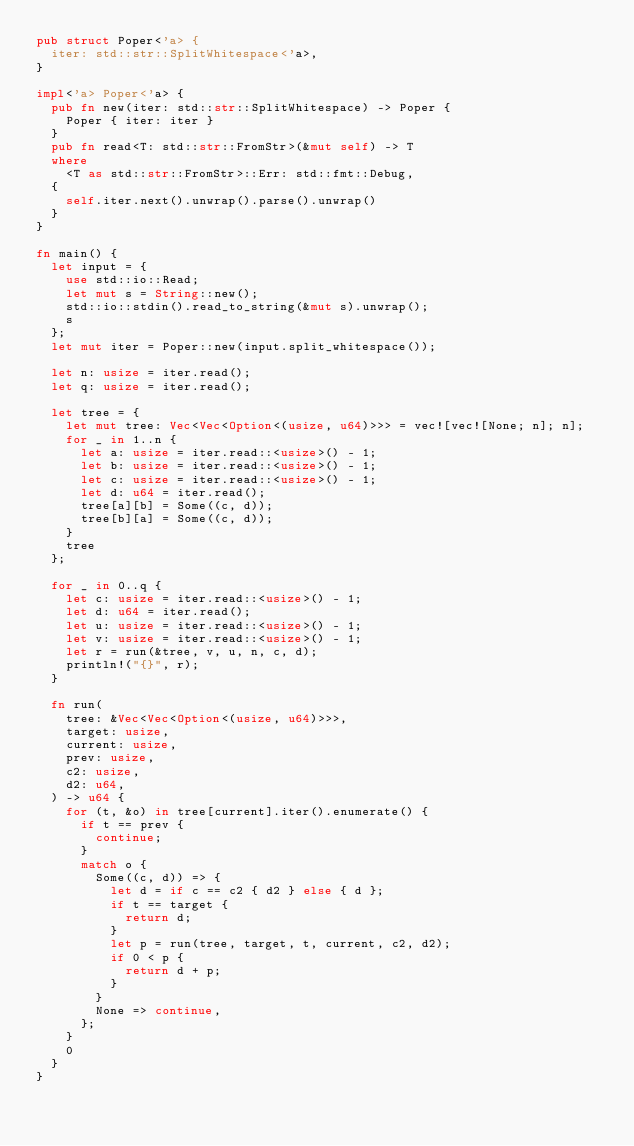Convert code to text. <code><loc_0><loc_0><loc_500><loc_500><_Rust_>pub struct Poper<'a> {
	iter: std::str::SplitWhitespace<'a>,
}

impl<'a> Poper<'a> {
	pub fn new(iter: std::str::SplitWhitespace) -> Poper {
		Poper { iter: iter }
	}
	pub fn read<T: std::str::FromStr>(&mut self) -> T
	where
		<T as std::str::FromStr>::Err: std::fmt::Debug,
	{
		self.iter.next().unwrap().parse().unwrap()
	}
}

fn main() {
	let input = {
		use std::io::Read;
		let mut s = String::new();
		std::io::stdin().read_to_string(&mut s).unwrap();
		s
	};
	let mut iter = Poper::new(input.split_whitespace());

	let n: usize = iter.read();
	let q: usize = iter.read();

	let tree = {
		let mut tree: Vec<Vec<Option<(usize, u64)>>> = vec![vec![None; n]; n];
		for _ in 1..n {
			let a: usize = iter.read::<usize>() - 1;
			let b: usize = iter.read::<usize>() - 1;
			let c: usize = iter.read::<usize>() - 1;
			let d: u64 = iter.read();
			tree[a][b] = Some((c, d));
			tree[b][a] = Some((c, d));
		}
		tree
	};

	for _ in 0..q {
		let c: usize = iter.read::<usize>() - 1;
		let d: u64 = iter.read();
		let u: usize = iter.read::<usize>() - 1;
		let v: usize = iter.read::<usize>() - 1;
		let r = run(&tree, v, u, n, c, d);
		println!("{}", r);
	}

	fn run(
		tree: &Vec<Vec<Option<(usize, u64)>>>,
		target: usize,
		current: usize,
		prev: usize,
		c2: usize,
		d2: u64,
	) -> u64 {
		for (t, &o) in tree[current].iter().enumerate() {
			if t == prev {
				continue;
			}
			match o {
				Some((c, d)) => {
					let d = if c == c2 { d2 } else { d };
					if t == target {
						return d;
					}
					let p = run(tree, target, t, current, c2, d2);
					if 0 < p {
						return d + p;
					}
				}
				None => continue,
			};
		}
		0
	}
}
</code> 